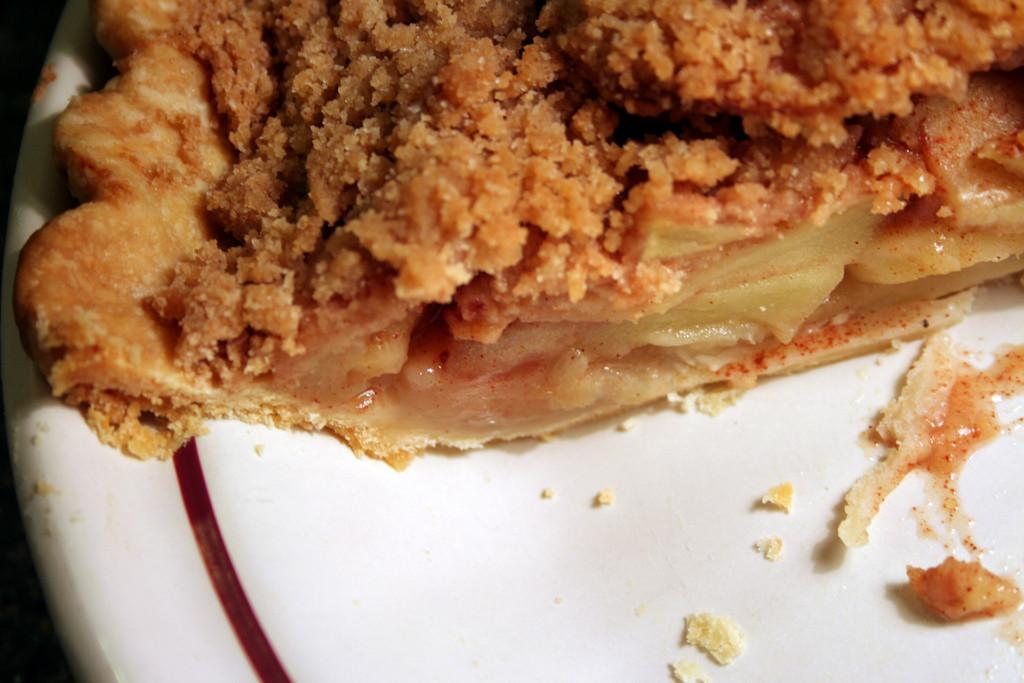What is on the plate that is visible in the image? There is food on a plate in the image. What type of meat is being hammered in the image? There is no meat or hammer present in the image. 